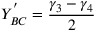Convert formula to latex. <formula><loc_0><loc_0><loc_500><loc_500>Y _ { B C } ^ { ^ { \prime } } = \frac { \gamma _ { 3 } - { \gamma _ { 4 } } } { 2 }</formula> 